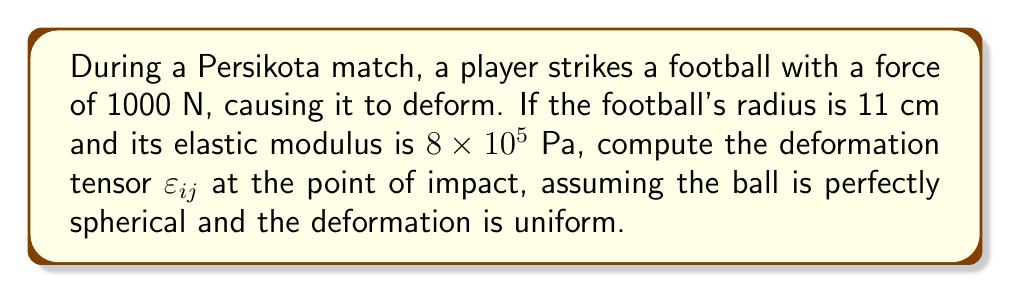Show me your answer to this math problem. To compute the deformation tensor, we'll follow these steps:

1) The deformation tensor $\varepsilon_{ij}$ for a uniform spherical deformation is given by:

   $$\varepsilon_{ij} = \frac{\Delta R}{R} \delta_{ij}$$

   where $\Delta R$ is the change in radius, $R$ is the original radius, and $\delta_{ij}$ is the Kronecker delta.

2) We need to find $\Delta R$. For this, we can use Hooke's law in three dimensions:

   $$\sigma = E \cdot \varepsilon$$

   where $\sigma$ is stress, $E$ is the elastic modulus, and $\varepsilon$ is strain.

3) Stress $\sigma$ is force per unit area. The area of impact can be approximated as $\pi r^2$, where $r$ is the radius of the impact area (let's assume it's 1 cm):

   $$\sigma = \frac{F}{A} = \frac{1000 \text{ N}}{\pi (0.01 \text{ m})^2} \approx 3.18 \times 10^6 \text{ Pa}$$

4) Now we can find the strain $\varepsilon$:

   $$\varepsilon = \frac{\sigma}{E} = \frac{3.18 \times 10^6 \text{ Pa}}{8 \times 10^5 \text{ Pa}} = 3.975$$

5) The strain $\varepsilon$ is equal to $\frac{\Delta R}{R}$, so:

   $$\frac{\Delta R}{R} = 3.975$$
   $$\Delta R = 3.975 \cdot R = 3.975 \cdot 0.11 \text{ m} = 0.43725 \text{ m}$$

6) Now we can compute the deformation tensor:

   $$\varepsilon_{ij} = \frac{\Delta R}{R} \delta_{ij} = 3.975 \delta_{ij}$$

Therefore, the deformation tensor is:

$$\varepsilon_{ij} = 3.975 \begin{pmatrix}
1 & 0 & 0 \\
0 & 1 & 0 \\
0 & 0 & 1
\end{pmatrix}$$
Answer: $\varepsilon_{ij} = 3.975 \delta_{ij}$ 